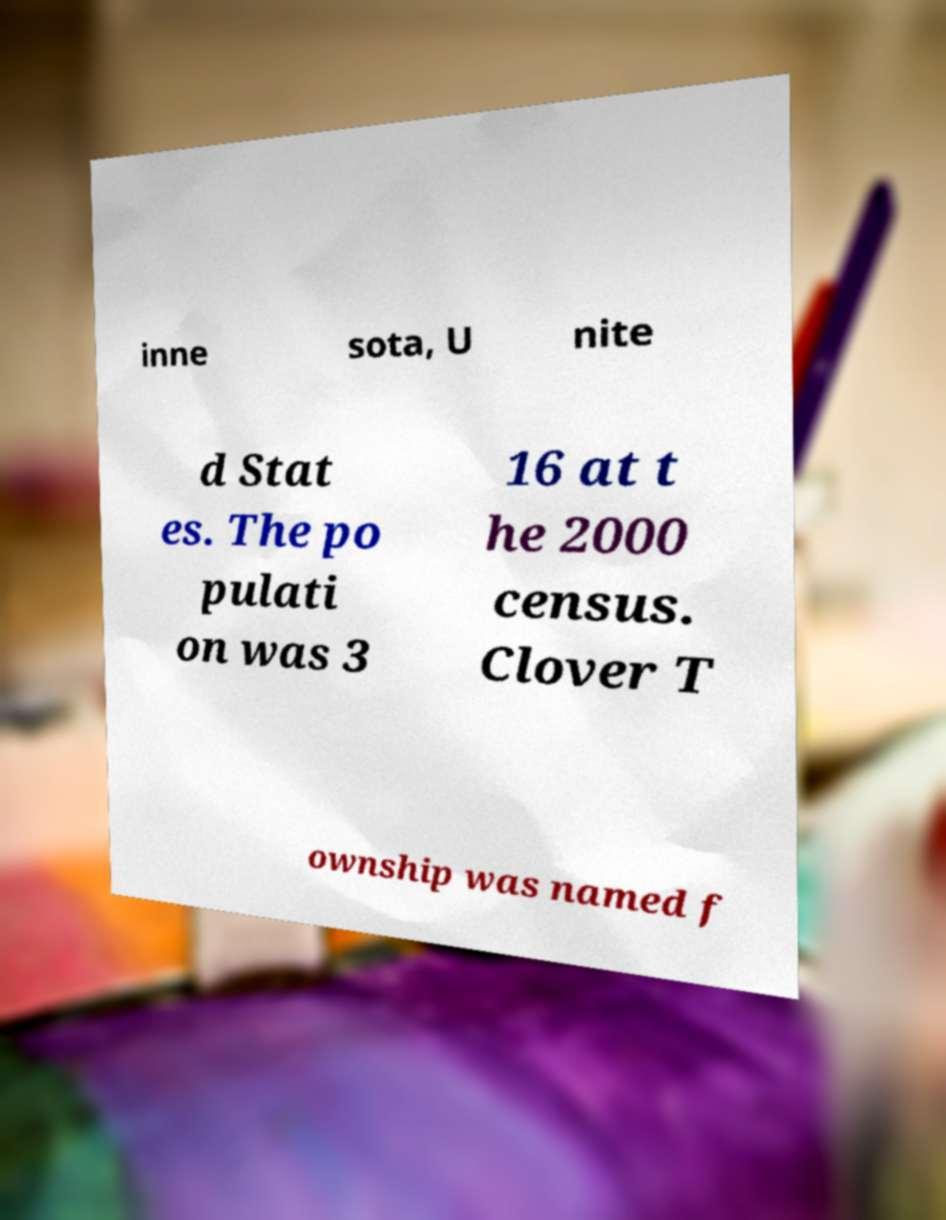Please read and relay the text visible in this image. What does it say? inne sota, U nite d Stat es. The po pulati on was 3 16 at t he 2000 census. Clover T ownship was named f 